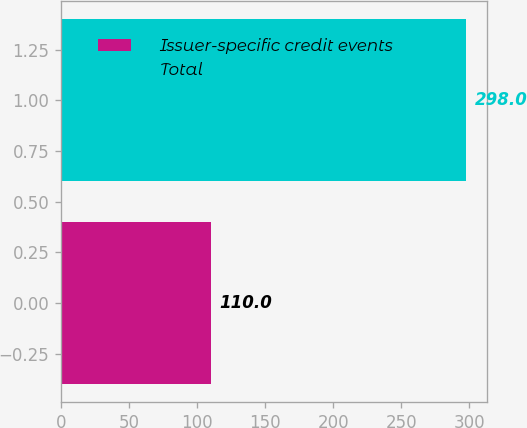Convert chart. <chart><loc_0><loc_0><loc_500><loc_500><bar_chart><fcel>Issuer-specific credit events<fcel>Total<nl><fcel>110<fcel>298<nl></chart> 